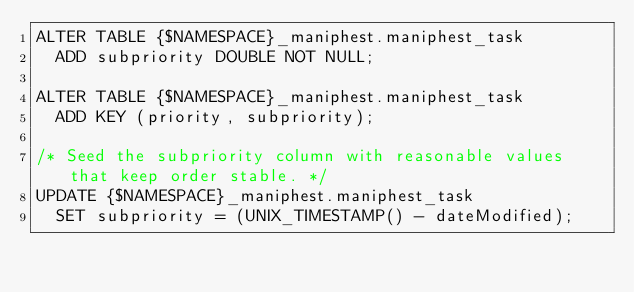Convert code to text. <code><loc_0><loc_0><loc_500><loc_500><_SQL_>ALTER TABLE {$NAMESPACE}_maniphest.maniphest_task
  ADD subpriority DOUBLE NOT NULL;

ALTER TABLE {$NAMESPACE}_maniphest.maniphest_task
  ADD KEY (priority, subpriority);

/* Seed the subpriority column with reasonable values that keep order stable. */
UPDATE {$NAMESPACE}_maniphest.maniphest_task
  SET subpriority = (UNIX_TIMESTAMP() - dateModified);
</code> 